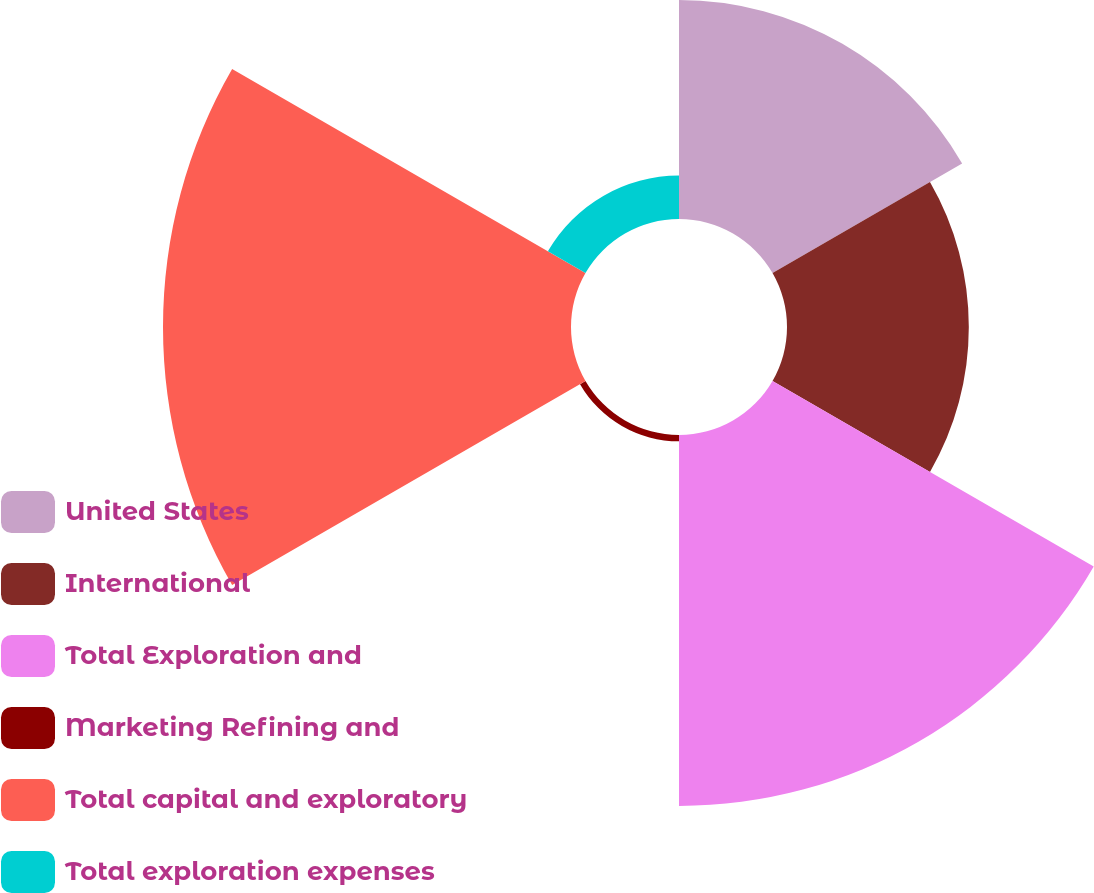Convert chart to OTSL. <chart><loc_0><loc_0><loc_500><loc_500><pie_chart><fcel>United States<fcel>International<fcel>Total Exploration and<fcel>Marketing Refining and<fcel>Total capital and exploratory<fcel>Total exploration expenses<nl><fcel>17.81%<fcel>14.79%<fcel>30.17%<fcel>0.51%<fcel>33.19%<fcel>3.53%<nl></chart> 